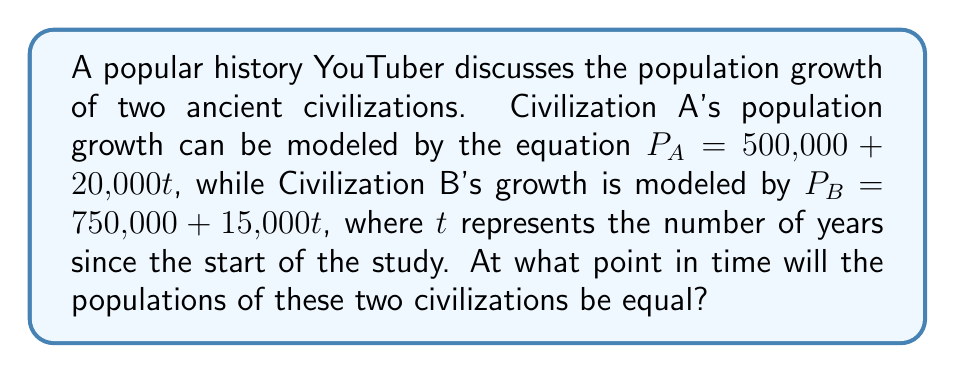Provide a solution to this math problem. To solve this problem, we need to set up a system of linear equations and find the point where the two populations are equal. Let's approach this step-by-step:

1) We have two equations:
   $P_A = 500,000 + 20,000t$
   $P_B = 750,000 + 15,000t$

2) For the populations to be equal, we can set $P_A = P_B$:
   $500,000 + 20,000t = 750,000 + 15,000t$

3) Now we have one equation to solve:
   $500,000 + 20,000t = 750,000 + 15,000t$

4) Subtract 500,000 from both sides:
   $20,000t = 250,000 + 15,000t$

5) Subtract 15,000t from both sides:
   $5,000t = 250,000$

6) Divide both sides by 5,000:
   $t = 50$

Therefore, the populations will be equal after 50 years.

7) To verify, we can plug this value back into both original equations:
   $P_A = 500,000 + 20,000(50) = 1,500,000$
   $P_B = 750,000 + 15,000(50) = 1,500,000$

Indeed, both populations are equal at 1,500,000 after 50 years.
Answer: $t = 50$ years 